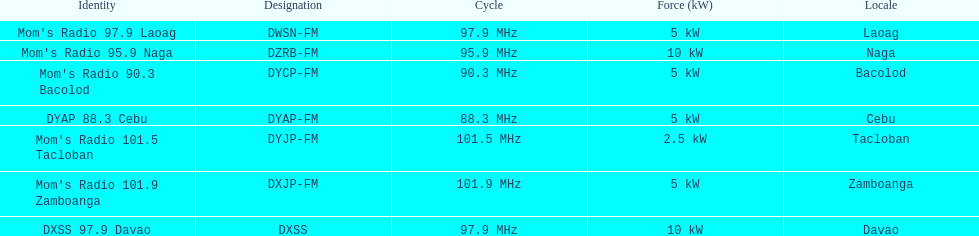What are the total number of radio stations on this list? 7. 